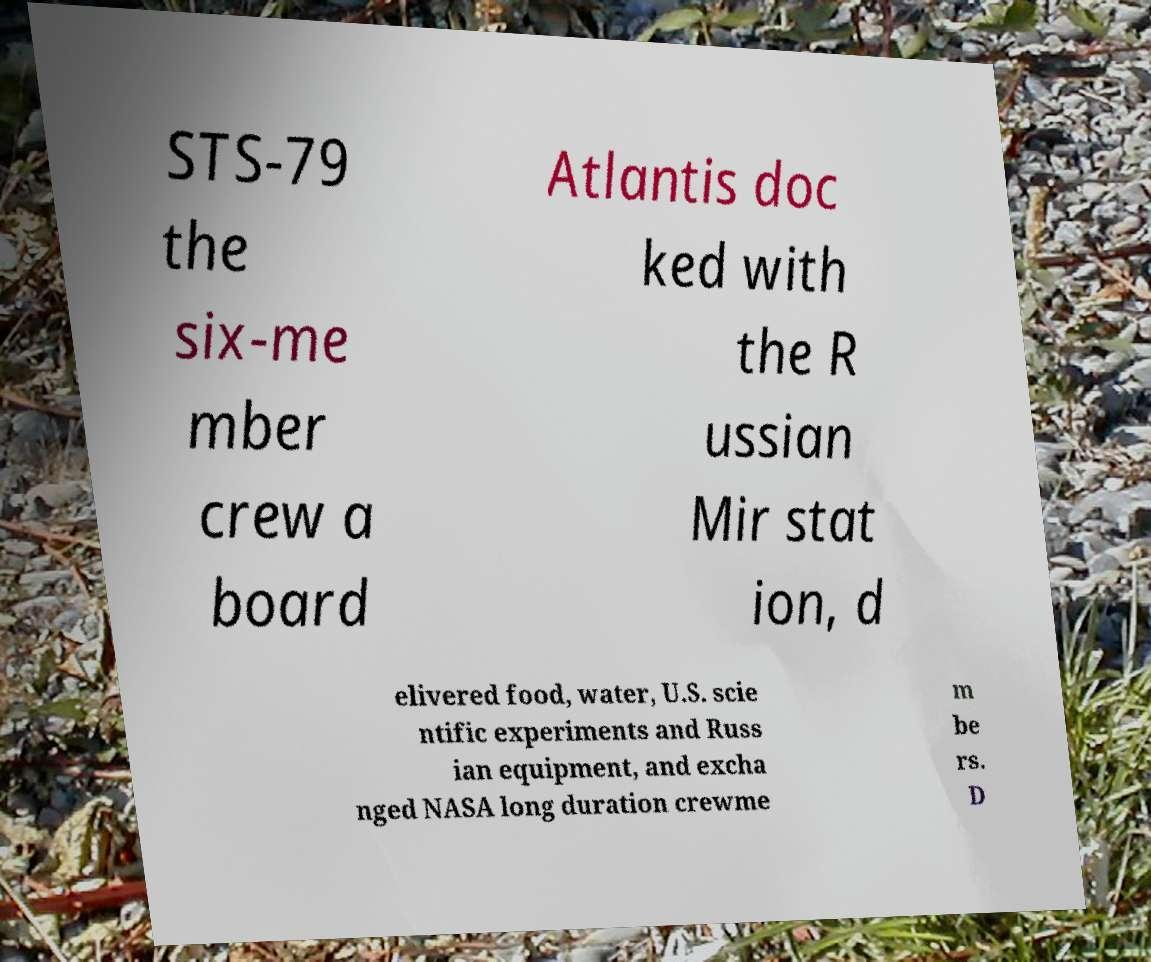What messages or text are displayed in this image? I need them in a readable, typed format. STS-79 the six-me mber crew a board Atlantis doc ked with the R ussian Mir stat ion, d elivered food, water, U.S. scie ntific experiments and Russ ian equipment, and excha nged NASA long duration crewme m be rs. D 